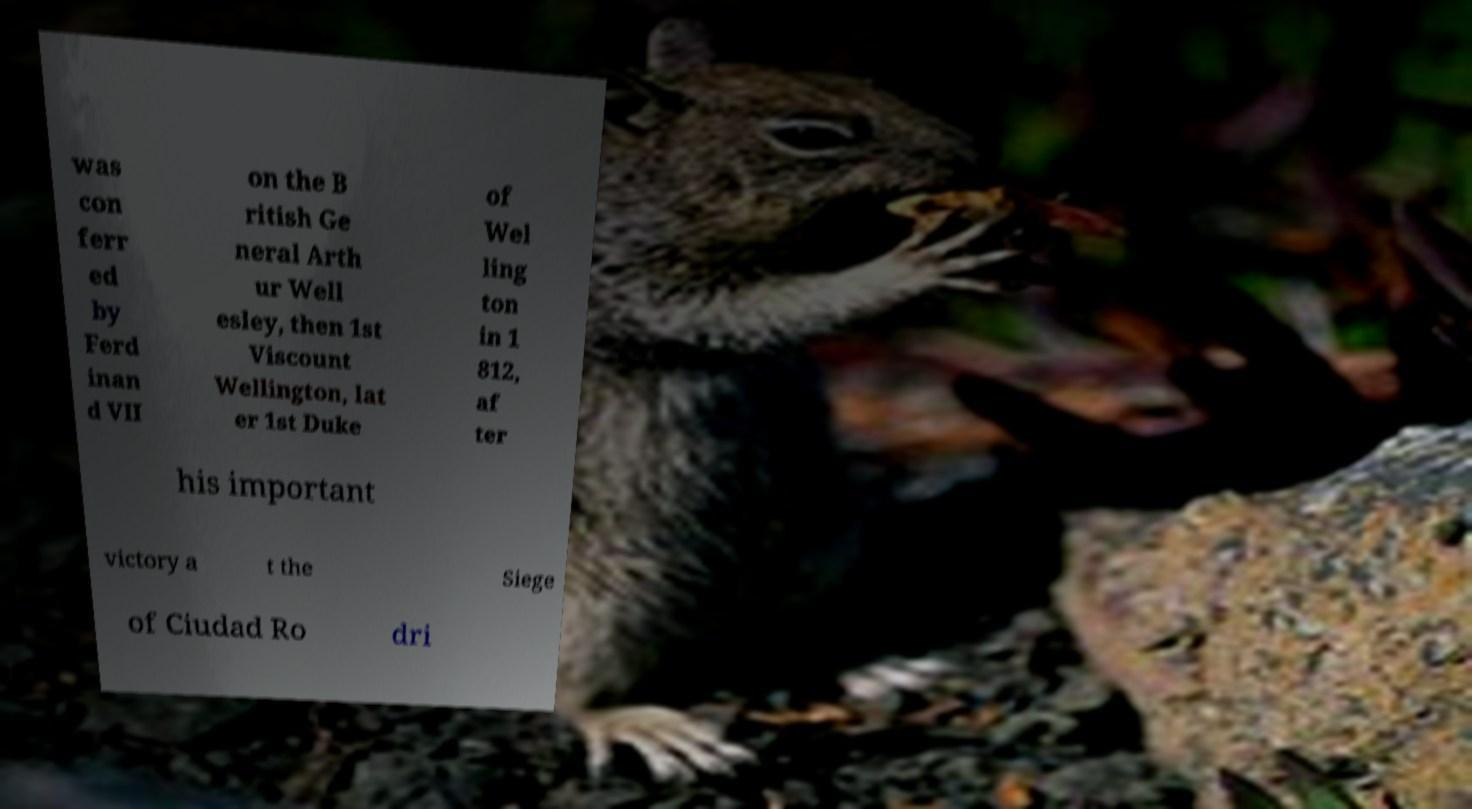I need the written content from this picture converted into text. Can you do that? was con ferr ed by Ferd inan d VII on the B ritish Ge neral Arth ur Well esley, then 1st Viscount Wellington, lat er 1st Duke of Wel ling ton in 1 812, af ter his important victory a t the Siege of Ciudad Ro dri 